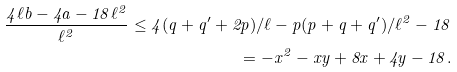<formula> <loc_0><loc_0><loc_500><loc_500>\frac { 4 \ell b - 4 a - 1 8 \ell ^ { 2 } } { \ell ^ { 2 } } \leq 4 ( q + q ^ { \prime } + 2 p ) / \ell - p ( p + q + q ^ { \prime } ) / \ell ^ { 2 } - 1 8 \\ = - x ^ { 2 } - x y + 8 x + 4 y - 1 8 .</formula> 